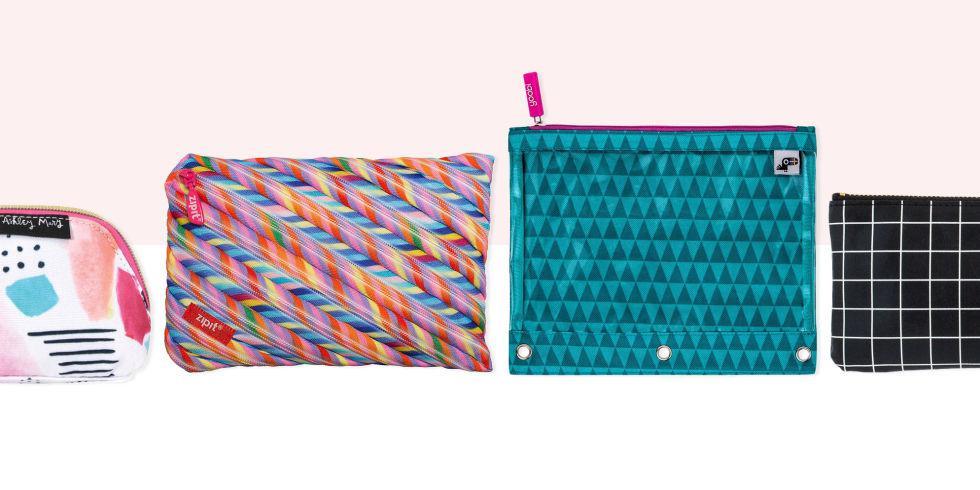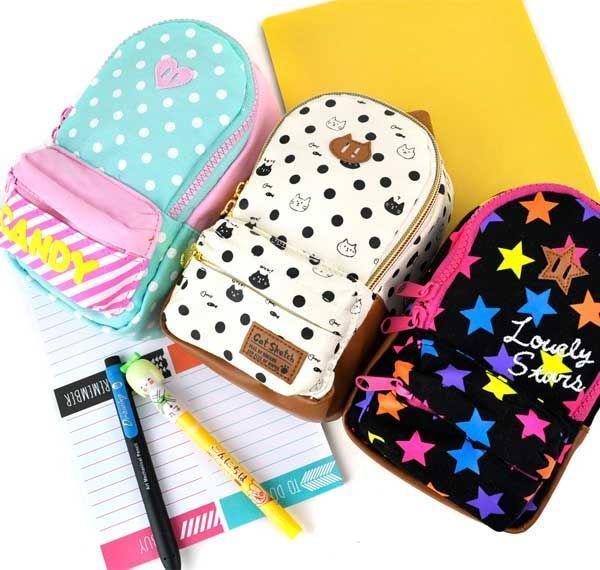The first image is the image on the left, the second image is the image on the right. Evaluate the accuracy of this statement regarding the images: "The left image shows exactly one pencil case.". Is it true? Answer yes or no. No. 